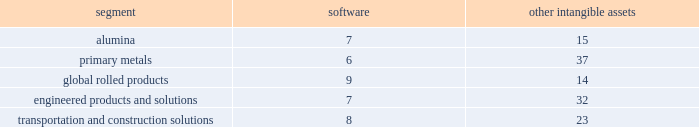During the 2015 annual review of goodwill , management proceeded directly to the two-step quantitative impairment test for two reporting units as follows : global rolled products segment and the soft alloys extrusion business in brazil ( hereafter 201csae 201d ) , which is included in the transportation and construction solutions segment .
The estimated fair value of the global rolled products segment was substantially in excess of its respective carrying value , resulting in no impairment .
For sae , the estimated fair value as determined by the dcf model was lower than the associated carrying value .
As a result , management performed the second step of the impairment analysis in order to determine the implied fair value of the sae reporting unit 2019s goodwill .
The results of the second-step analysis showed that the implied fair value of the goodwill was zero .
Therefore , in the fourth quarter of 2015 , alcoa recorded a goodwill impairment of $ 25 .
The impairment of the sae goodwill resulted from headwinds from the recent downturn in the brazilian economy and the continued erosion of gross margin despite the execution of cost reduction strategies .
As a result of the goodwill impairment , there is no goodwill remaining for the sae reporting unit .
Goodwill impairment tests in prior years indicated that goodwill was not impaired for any of the company 2019s reporting units , except for the primary metals segment in 2013 ( see below ) , and there were no triggering events since that time that necessitated an impairment test .
In 2013 , for primary metals , the estimated fair value as determined by the dcf model was lower than the associated carrying value .
As a result , management performed the second step of the impairment analysis in order to determine the implied fair value of primary metals 2019 goodwill .
The results of the second-step analysis showed that the implied fair value of goodwill was zero .
Therefore , in the fourth quarter of 2013 , alcoa recorded a goodwill impairment of $ 1731 ( $ 1719 after noncontrolling interest ) .
As a result of the goodwill impairment , there is no goodwill remaining for the primary metals reporting unit .
The impairment of primary metals 2019 goodwill resulted from several causes : the prolonged economic downturn ; a disconnect between industry fundamentals and pricing that has resulted in lower metal prices ; and the increased cost of alumina , a key raw material , resulting from expansion of the alumina price index throughout the industry .
All of these factors , exacerbated by increases in discount rates , continue to place significant downward pressure on metal prices and operating margins , and the resulting estimated fair value , of the primary metals business .
As a result , management decreased the near-term and long-term estimates of the operating results and cash flows utilized in assessing primary metals 2019 goodwill for impairment .
The valuation of goodwill for the second step of the goodwill impairment analysis is considered a level 3 fair value measurement , which means that the valuation of the assets and liabilities reflect management 2019s own judgments regarding the assumptions market participants would use in determining the fair value of the assets and liabilities .
Intangible assets with indefinite useful lives are not amortized while intangible assets with finite useful lives are amortized generally on a straight-line basis over the periods benefited .
The table details the weighted- average useful lives of software and other intangible assets by reporting segment ( numbers in years ) : .
Equity investments .
Alcoa invests in a number of privately-held companies , primarily through joint ventures and consortia , which are accounted for using the equity method .
The equity method is applied in situations where alcoa has the ability to exercise significant influence , but not control , over the investee .
Management reviews equity investments for impairment whenever certain indicators are present suggesting that the carrying value of an investment is not recoverable .
This analysis requires a significant amount of judgment from management to identify events or circumstances indicating that an equity investment is impaired .
The following items are examples of impairment indicators : significant , sustained declines in an investee 2019s revenue , earnings , and cash .
What is the variation between the weighted- average useful lives of software and other intangible assets by primary metals segment , in years? 
Rationale: it is the difference between the number of years of software and other intangible assets .
Computations: (37 - 6)
Answer: 31.0. 